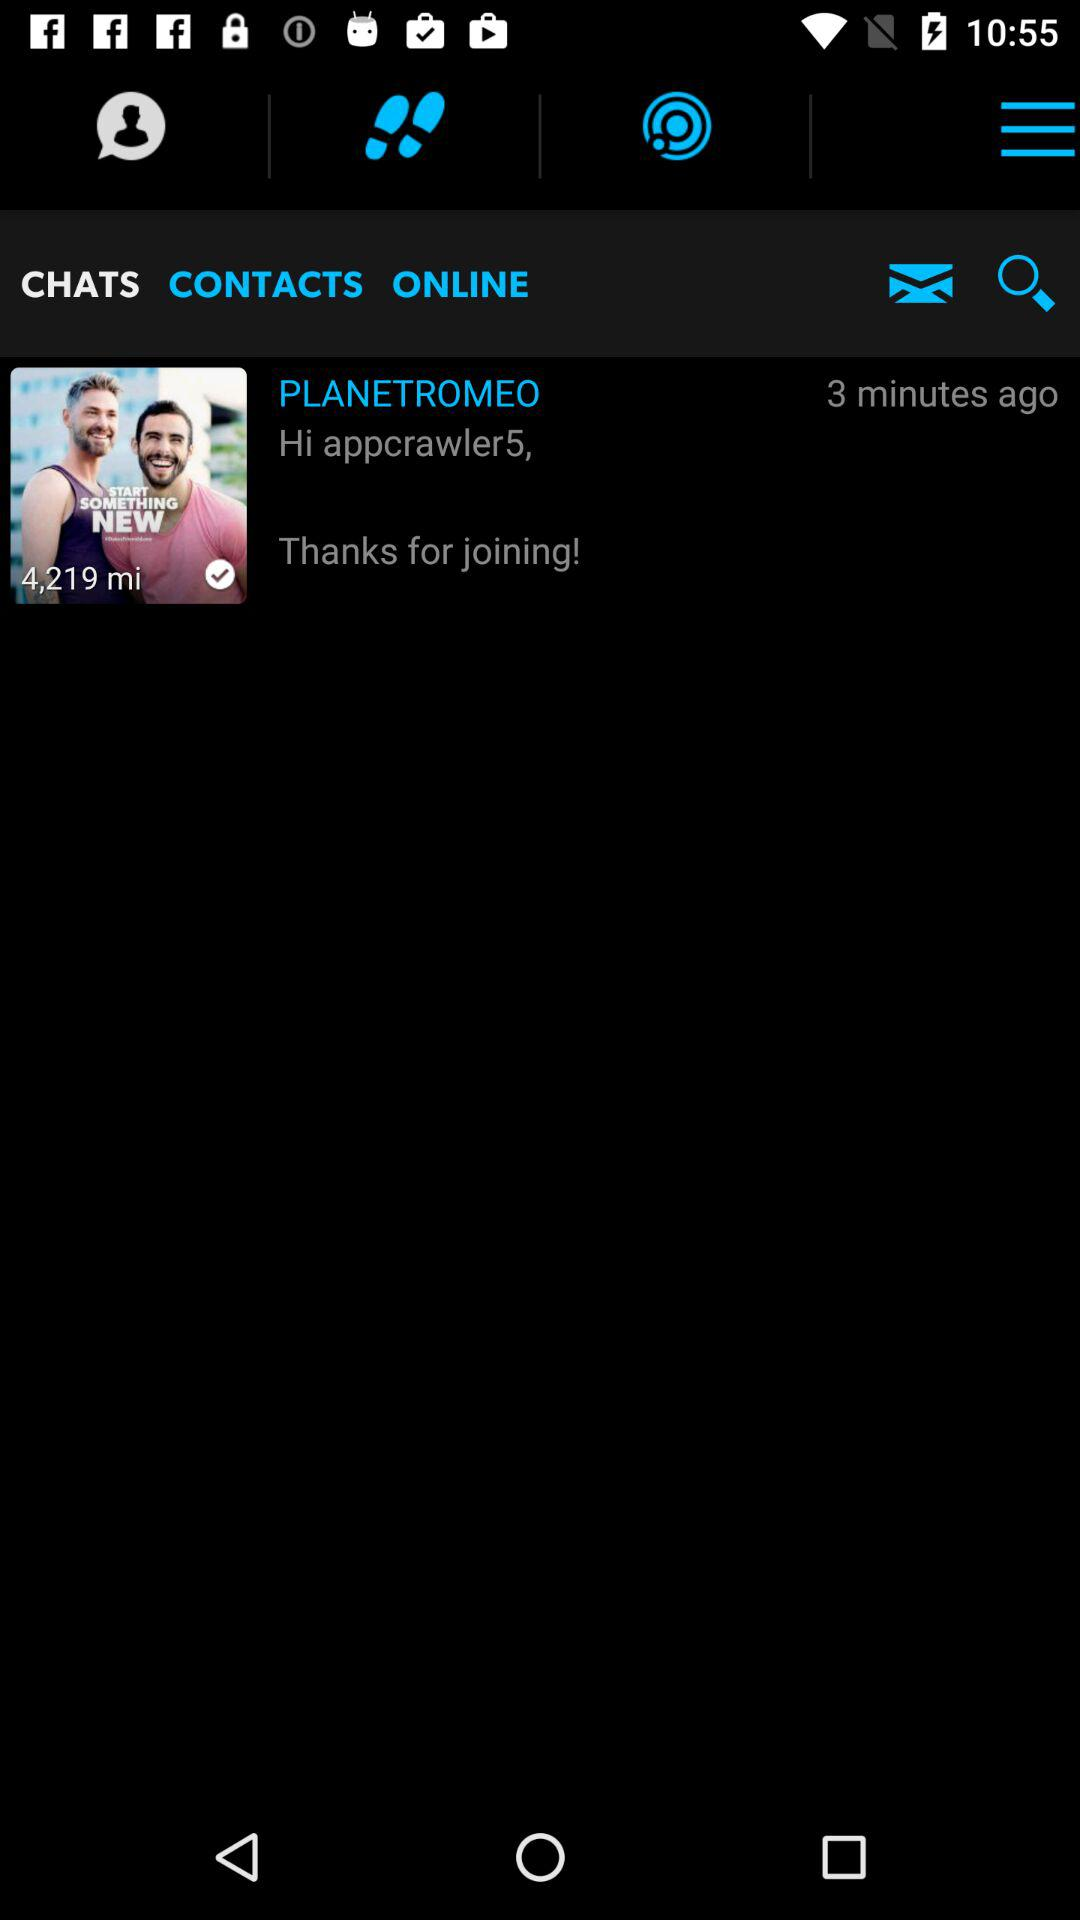How many more people are in the conversation than in the picture?
Answer the question using a single word or phrase. 1 